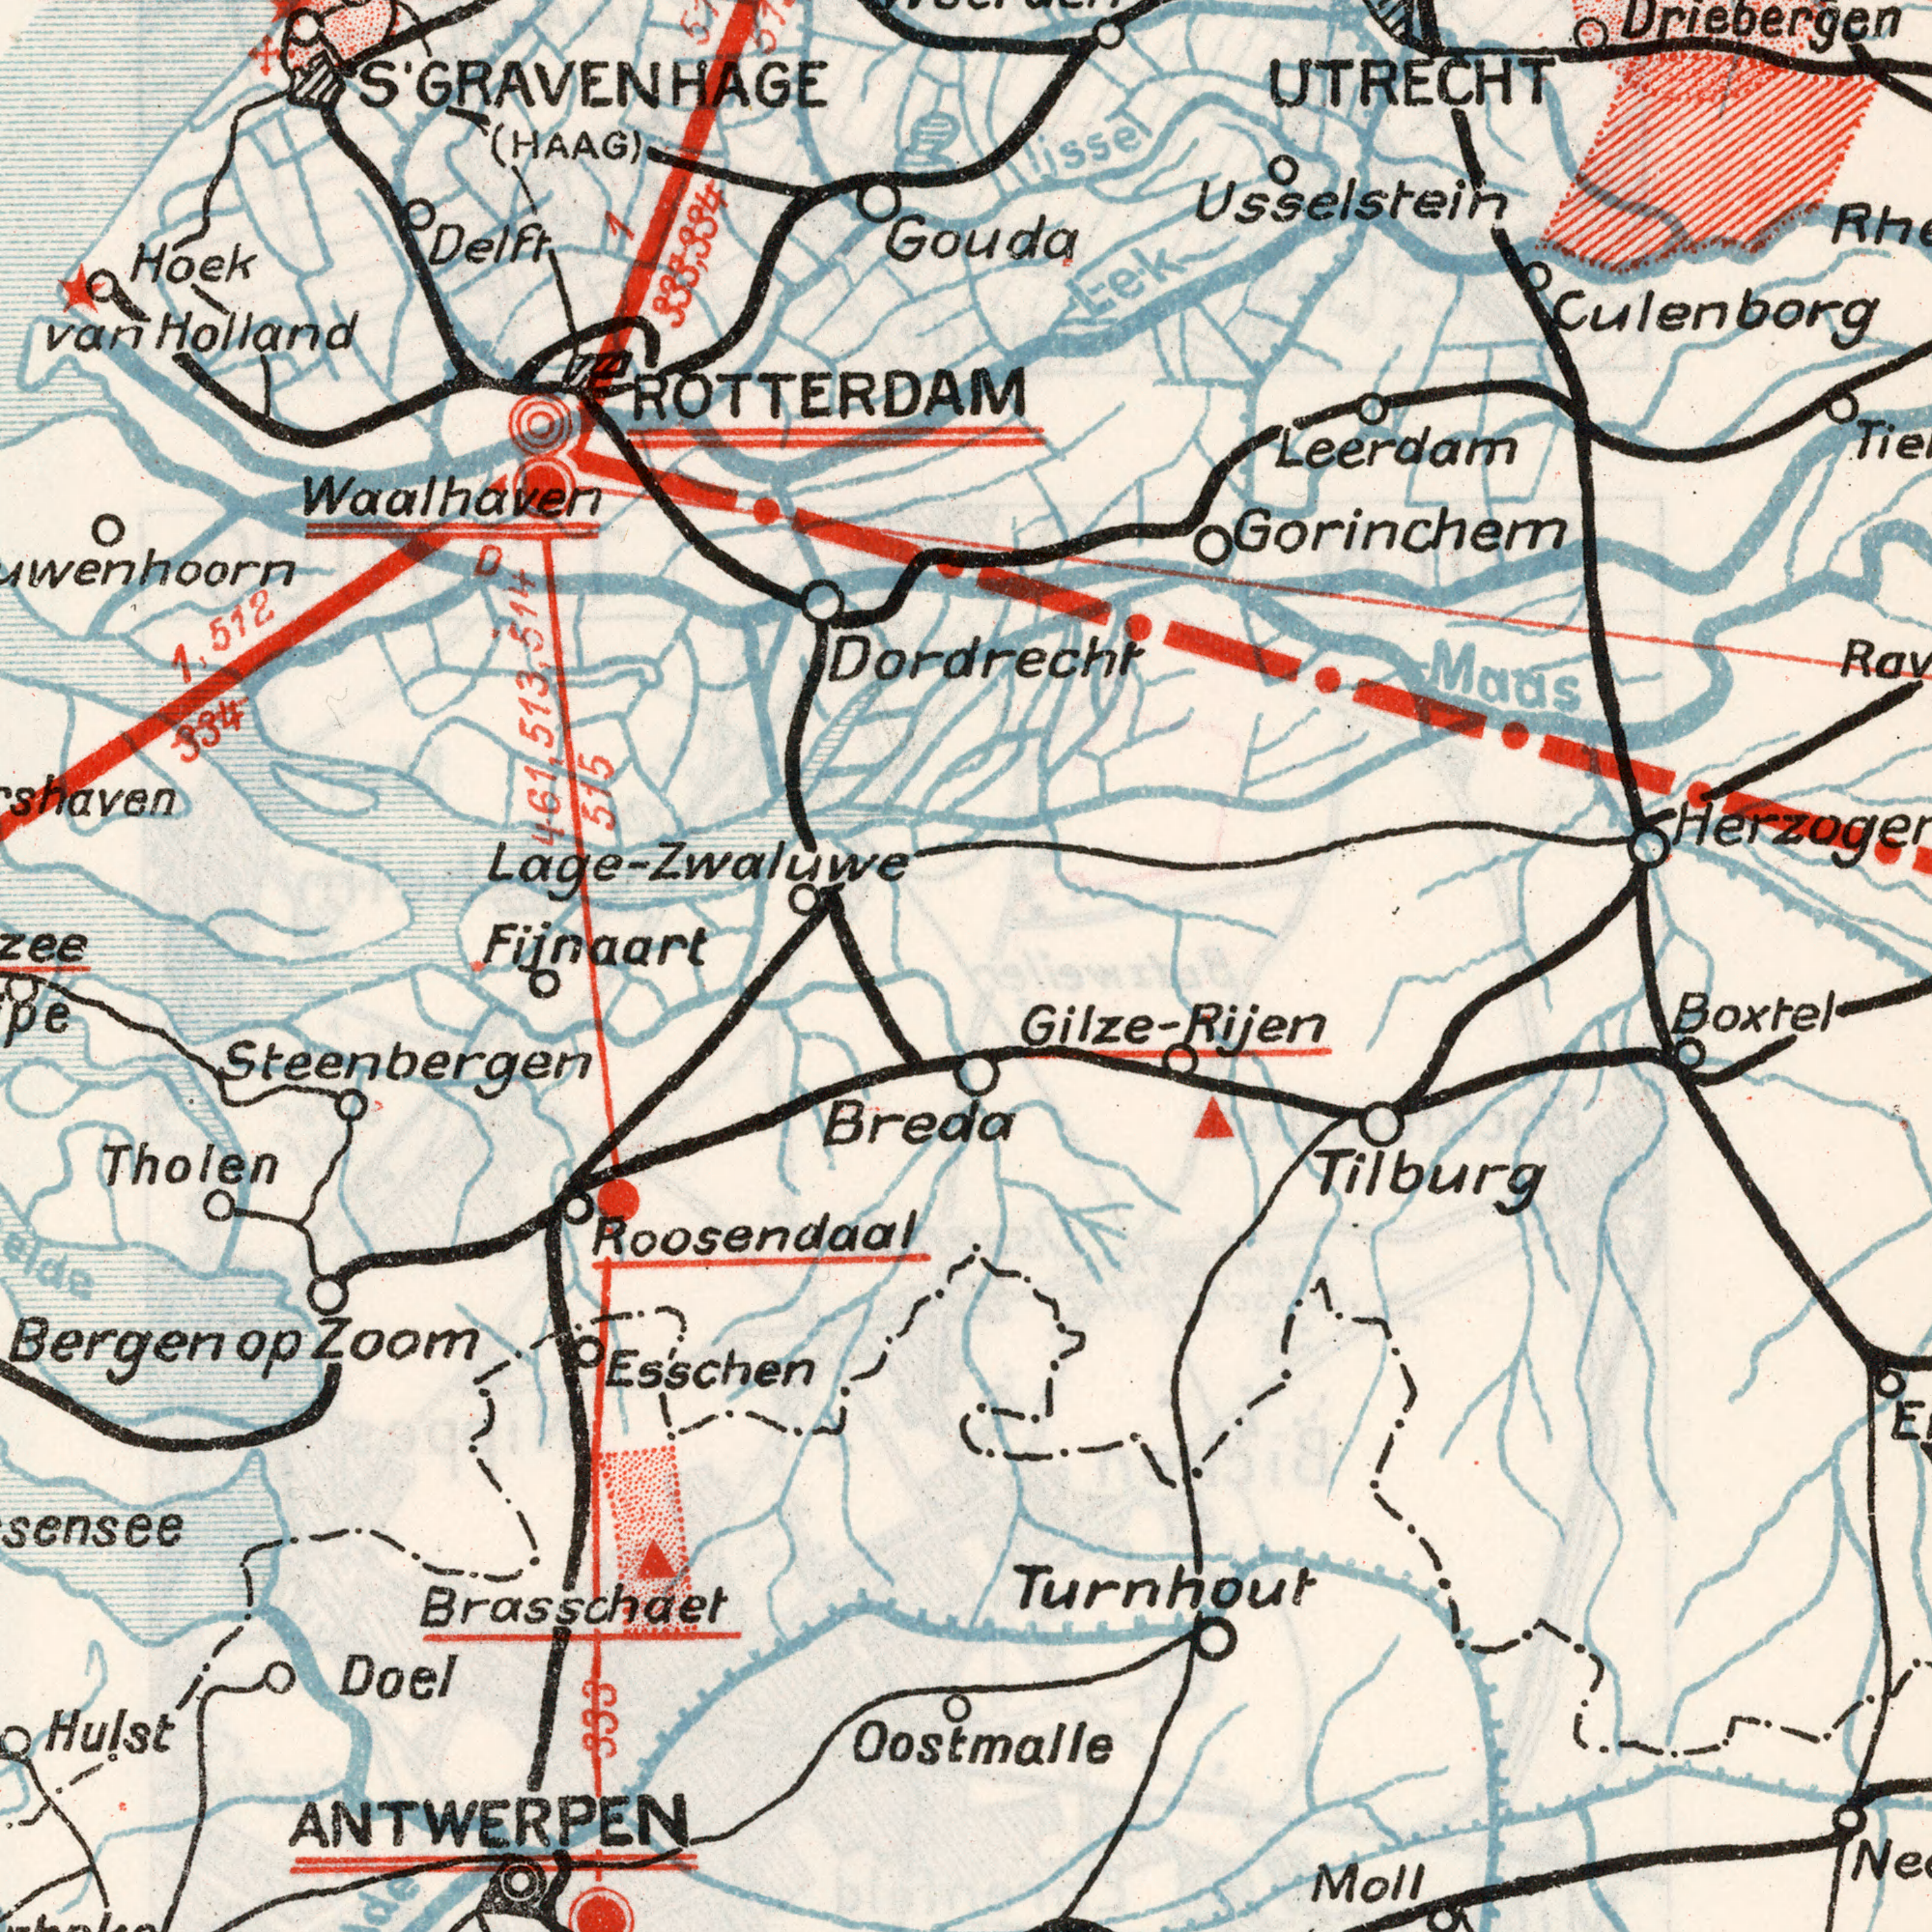What text can you see in the bottom-right section? Oostmalle Boxtel Turnhout Moll Tilburg Gilze- Rijen What text appears in the bottom-left area of the image? Doel Tholen Hulst Bergenop Breda Esschen Roosendaal Zoom ANTWERPEN Brasschaet Steenbergen 333 What text appears in the top-left area of the image? Fijnaart Hoek (HAAG) Waalhaven van 1,512 334 Holland Delft S'GRAVENHAGE ROTTERDAM Lage- 1 333,334 D 461, 513, 514 515 Zwaluwe What text appears in the top-right area of the image? Gouda Leerdam Maas Gorinchem Dordrecht Lek Culenborg UTRECHT Usselstein Driebergen Lissel 